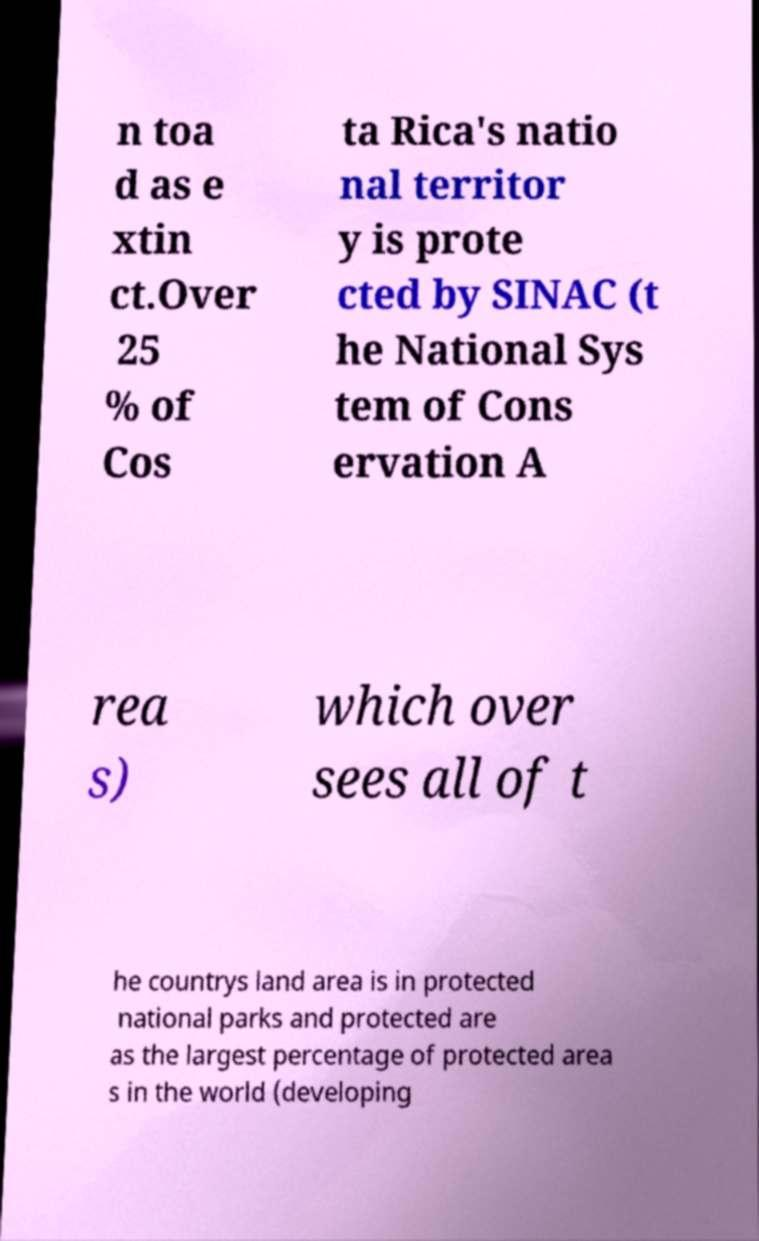Could you extract and type out the text from this image? n toa d as e xtin ct.Over 25 % of Cos ta Rica's natio nal territor y is prote cted by SINAC (t he National Sys tem of Cons ervation A rea s) which over sees all of t he countrys land area is in protected national parks and protected are as the largest percentage of protected area s in the world (developing 